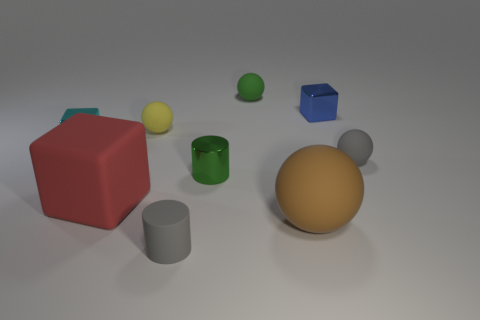Is there any other thing that is the same shape as the blue shiny thing?
Give a very brief answer. Yes. What number of things are cylinders behind the large brown rubber ball or tiny rubber blocks?
Keep it short and to the point. 1. Is the color of the small rubber object behind the yellow matte object the same as the big rubber cube?
Provide a short and direct response. No. There is a tiny gray thing right of the gray matte thing left of the big brown matte thing; what is its shape?
Your response must be concise. Sphere. Are there fewer green objects that are behind the metallic cylinder than cyan objects that are to the right of the tiny yellow matte thing?
Offer a very short reply. No. There is a gray object that is the same shape as the yellow matte object; what size is it?
Make the answer very short. Small. Are there any other things that have the same size as the yellow matte ball?
Make the answer very short. Yes. How many objects are either cylinders in front of the shiny cylinder or small shiny things that are right of the large red matte thing?
Offer a terse response. 3. Is the cyan cube the same size as the blue metal block?
Ensure brevity in your answer.  Yes. Is the number of red blocks greater than the number of tiny red metallic objects?
Keep it short and to the point. Yes. 